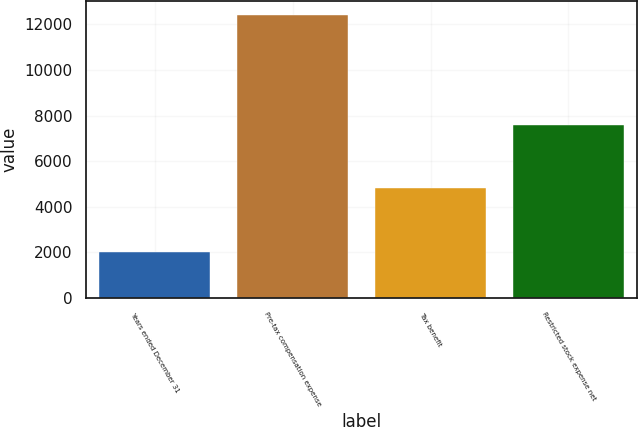Convert chart. <chart><loc_0><loc_0><loc_500><loc_500><bar_chart><fcel>Years ended December 31<fcel>Pre-tax compensation expense<fcel>Tax benefit<fcel>Restricted stock expense net<nl><fcel>2017<fcel>12399<fcel>4799<fcel>7600<nl></chart> 